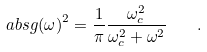Convert formula to latex. <formula><loc_0><loc_0><loc_500><loc_500>\ a b s { g ( \omega ) } ^ { 2 } = \frac { 1 } { \pi } \frac { \omega _ { c } ^ { 2 } } { \omega _ { c } ^ { 2 } + \omega ^ { 2 } } \quad .</formula> 